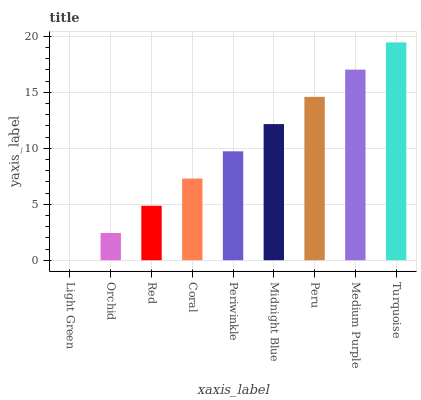Is Orchid the minimum?
Answer yes or no. No. Is Orchid the maximum?
Answer yes or no. No. Is Orchid greater than Light Green?
Answer yes or no. Yes. Is Light Green less than Orchid?
Answer yes or no. Yes. Is Light Green greater than Orchid?
Answer yes or no. No. Is Orchid less than Light Green?
Answer yes or no. No. Is Periwinkle the high median?
Answer yes or no. Yes. Is Periwinkle the low median?
Answer yes or no. Yes. Is Peru the high median?
Answer yes or no. No. Is Coral the low median?
Answer yes or no. No. 